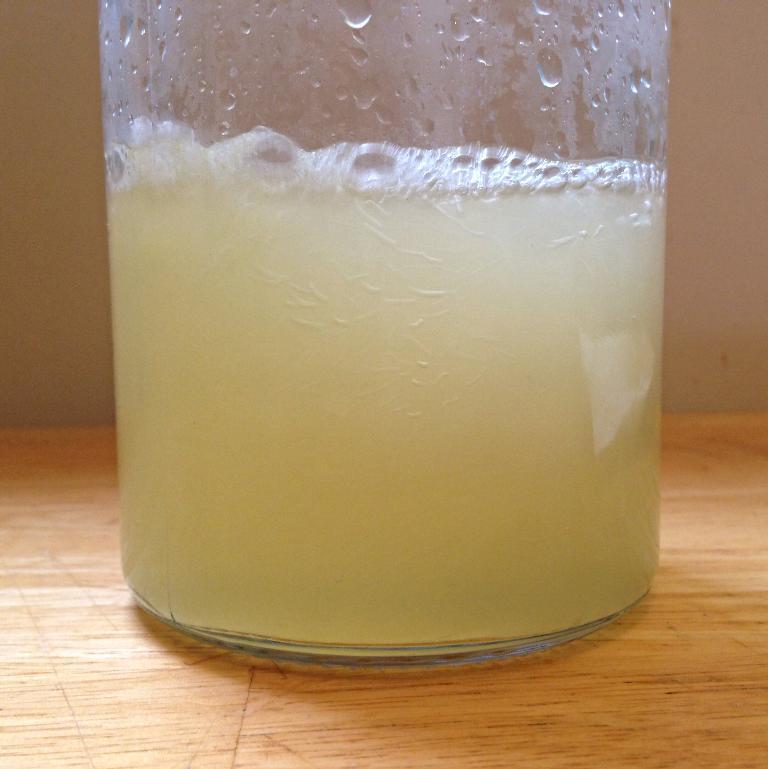Can you describe this image briefly? In the foreground of the picture we can see a glass, in the glass there is a drink. The glass is placed on a wooden table. In the background it might be wall. 